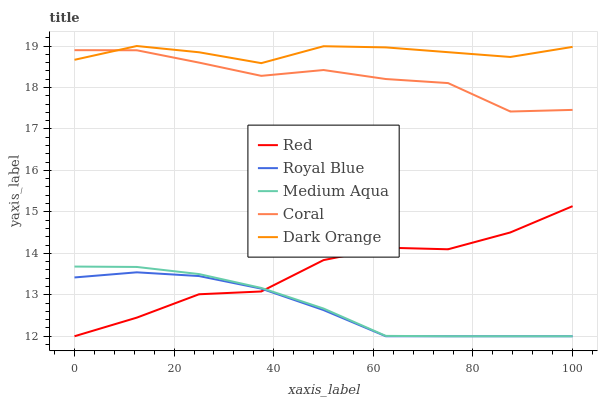Does Royal Blue have the minimum area under the curve?
Answer yes or no. Yes. Does Dark Orange have the maximum area under the curve?
Answer yes or no. Yes. Does Coral have the minimum area under the curve?
Answer yes or no. No. Does Coral have the maximum area under the curve?
Answer yes or no. No. Is Medium Aqua the smoothest?
Answer yes or no. Yes. Is Red the roughest?
Answer yes or no. Yes. Is Coral the smoothest?
Answer yes or no. No. Is Coral the roughest?
Answer yes or no. No. Does Royal Blue have the lowest value?
Answer yes or no. Yes. Does Coral have the lowest value?
Answer yes or no. No. Does Dark Orange have the highest value?
Answer yes or no. Yes. Does Coral have the highest value?
Answer yes or no. No. Is Red less than Coral?
Answer yes or no. Yes. Is Coral greater than Red?
Answer yes or no. Yes. Does Red intersect Medium Aqua?
Answer yes or no. Yes. Is Red less than Medium Aqua?
Answer yes or no. No. Is Red greater than Medium Aqua?
Answer yes or no. No. Does Red intersect Coral?
Answer yes or no. No. 